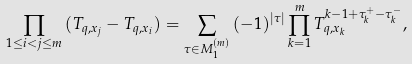Convert formula to latex. <formula><loc_0><loc_0><loc_500><loc_500>\prod _ { 1 \leq i < j \leq m } { ( T _ { q , x _ { j } } - T _ { q , x _ { i } } ) } = \sum _ { \tau \in M ^ { ( m ) } _ { 1 } } { ( - 1 ) ^ { | \tau | } \prod _ { k = 1 } ^ { m } { T _ { q , x _ { k } } ^ { k - 1 + \tau _ { k } ^ { + } - \tau _ { k } ^ { - } } } } ,</formula> 